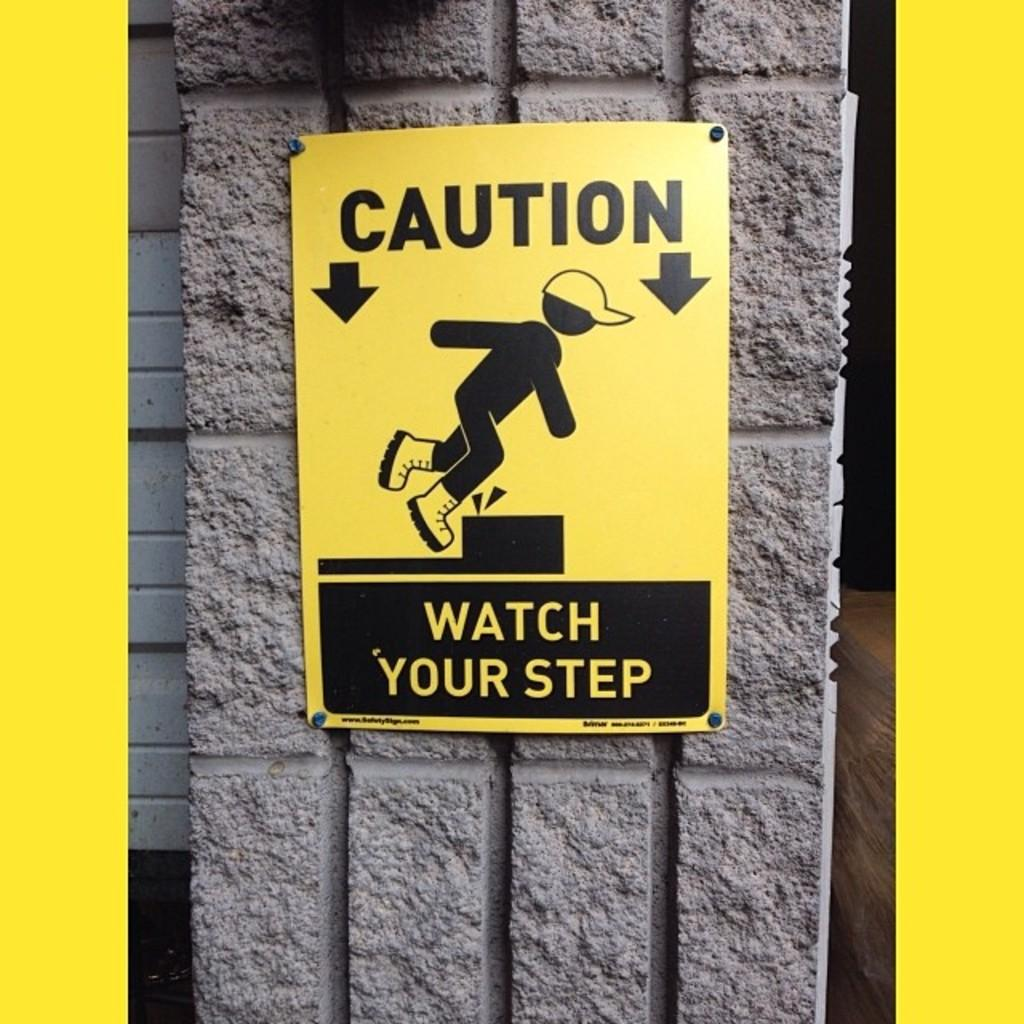What is the main structure in the image? There is a pillar in the image. What is attached to the pillar? There is a signboard on the pillar. What information can be found on the signboard? The signboard contains text. What type of image is present on the signboard? The signboard has a picture that resembles a human. What is the weather like in the image? The provided facts do not mention any information about the weather in the image. Can you tell me how many people are joining the event in the image? There is no event or people present in the image; it only features a pillar with a signboard. 